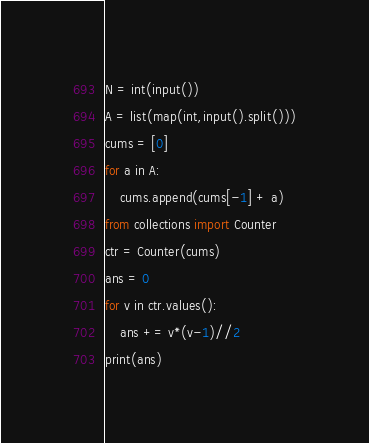<code> <loc_0><loc_0><loc_500><loc_500><_Python_>N = int(input())
A = list(map(int,input().split()))
cums = [0]
for a in A:
    cums.append(cums[-1] + a)
from collections import Counter
ctr = Counter(cums)
ans = 0
for v in ctr.values():
    ans += v*(v-1)//2
print(ans)</code> 